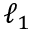<formula> <loc_0><loc_0><loc_500><loc_500>\ell _ { 1 }</formula> 